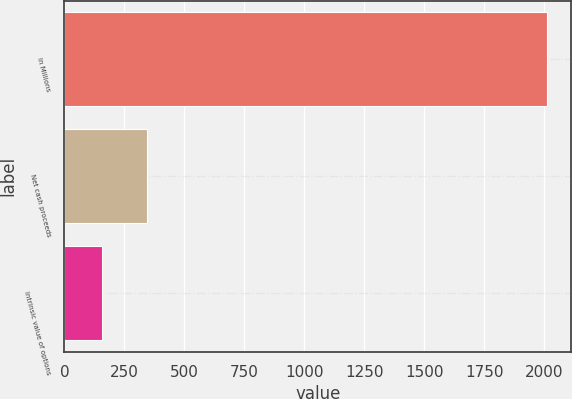Convert chart to OTSL. <chart><loc_0><loc_0><loc_500><loc_500><bar_chart><fcel>In Millions<fcel>Net cash proceeds<fcel>Intrinsic value of options<nl><fcel>2012<fcel>342.23<fcel>156.7<nl></chart> 